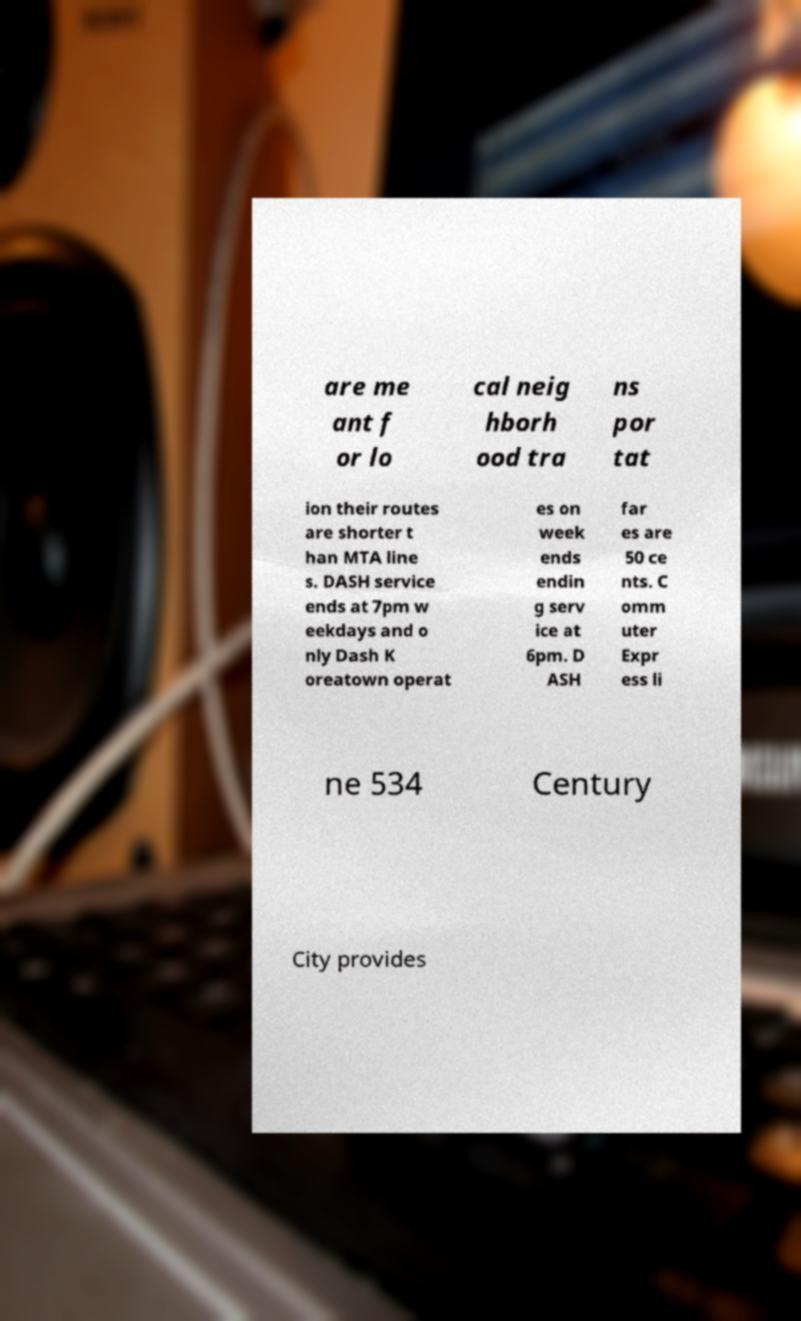For documentation purposes, I need the text within this image transcribed. Could you provide that? are me ant f or lo cal neig hborh ood tra ns por tat ion their routes are shorter t han MTA line s. DASH service ends at 7pm w eekdays and o nly Dash K oreatown operat es on week ends endin g serv ice at 6pm. D ASH far es are 50 ce nts. C omm uter Expr ess li ne 534 Century City provides 